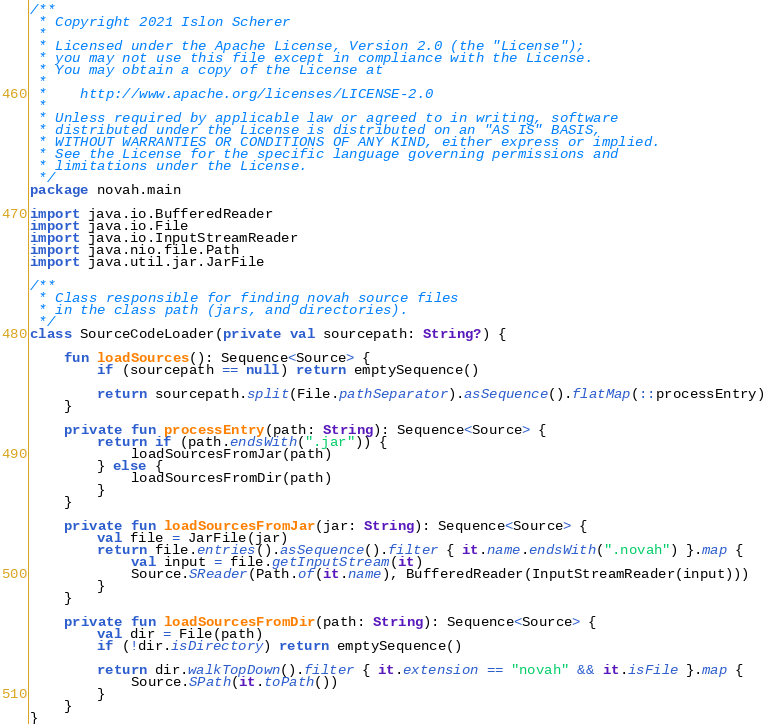<code> <loc_0><loc_0><loc_500><loc_500><_Kotlin_>/**
 * Copyright 2021 Islon Scherer
 *
 * Licensed under the Apache License, Version 2.0 (the "License");
 * you may not use this file except in compliance with the License.
 * You may obtain a copy of the License at
 *
 *    http://www.apache.org/licenses/LICENSE-2.0
 *
 * Unless required by applicable law or agreed to in writing, software
 * distributed under the License is distributed on an "AS IS" BASIS,
 * WITHOUT WARRANTIES OR CONDITIONS OF ANY KIND, either express or implied.
 * See the License for the specific language governing permissions and
 * limitations under the License.
 */
package novah.main

import java.io.BufferedReader
import java.io.File
import java.io.InputStreamReader
import java.nio.file.Path
import java.util.jar.JarFile

/**
 * Class responsible for finding novah source files
 * in the class path (jars, and directories).
 */
class SourceCodeLoader(private val sourcepath: String?) {

    fun loadSources(): Sequence<Source> {
        if (sourcepath == null) return emptySequence()

        return sourcepath.split(File.pathSeparator).asSequence().flatMap(::processEntry)
    }

    private fun processEntry(path: String): Sequence<Source> {
        return if (path.endsWith(".jar")) {
            loadSourcesFromJar(path)
        } else {
            loadSourcesFromDir(path)
        }
    }

    private fun loadSourcesFromJar(jar: String): Sequence<Source> {
        val file = JarFile(jar)
        return file.entries().asSequence().filter { it.name.endsWith(".novah") }.map {
            val input = file.getInputStream(it)
            Source.SReader(Path.of(it.name), BufferedReader(InputStreamReader(input)))
        }
    }

    private fun loadSourcesFromDir(path: String): Sequence<Source> {
        val dir = File(path)
        if (!dir.isDirectory) return emptySequence()

        return dir.walkTopDown().filter { it.extension == "novah" && it.isFile }.map {
            Source.SPath(it.toPath())
        }
    }
}</code> 